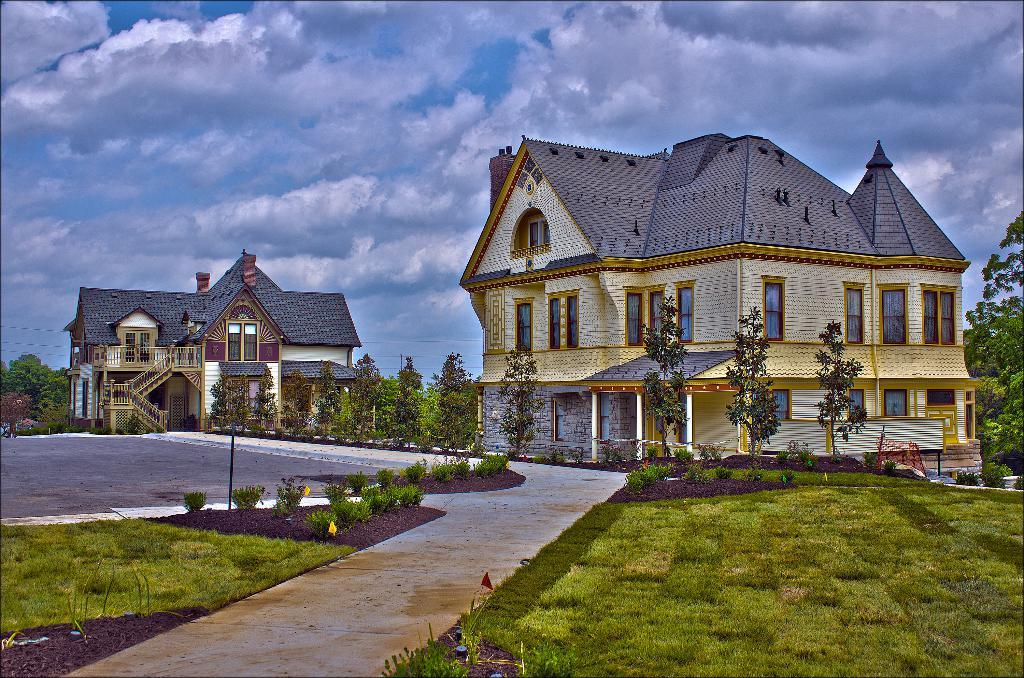How many buildings with windows are in the image? There are two buildings with windows in the image. What type of vegetation can be seen in the image? There are trees, plants, and grass in the image. What is the purpose of the pathway in the image? The pathway in the image provides a walkway or path for people to walk on. What is visible in the background of the image? The sky is visible in the background of the image. What activity is the visitor performing in the image? There is no visitor present in the image, so it is not possible to determine what activity they might be performing. 